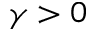<formula> <loc_0><loc_0><loc_500><loc_500>\gamma > 0</formula> 